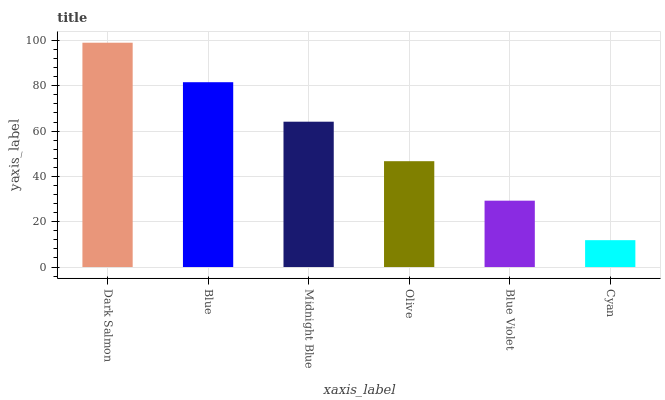Is Blue the minimum?
Answer yes or no. No. Is Blue the maximum?
Answer yes or no. No. Is Dark Salmon greater than Blue?
Answer yes or no. Yes. Is Blue less than Dark Salmon?
Answer yes or no. Yes. Is Blue greater than Dark Salmon?
Answer yes or no. No. Is Dark Salmon less than Blue?
Answer yes or no. No. Is Midnight Blue the high median?
Answer yes or no. Yes. Is Olive the low median?
Answer yes or no. Yes. Is Dark Salmon the high median?
Answer yes or no. No. Is Blue Violet the low median?
Answer yes or no. No. 